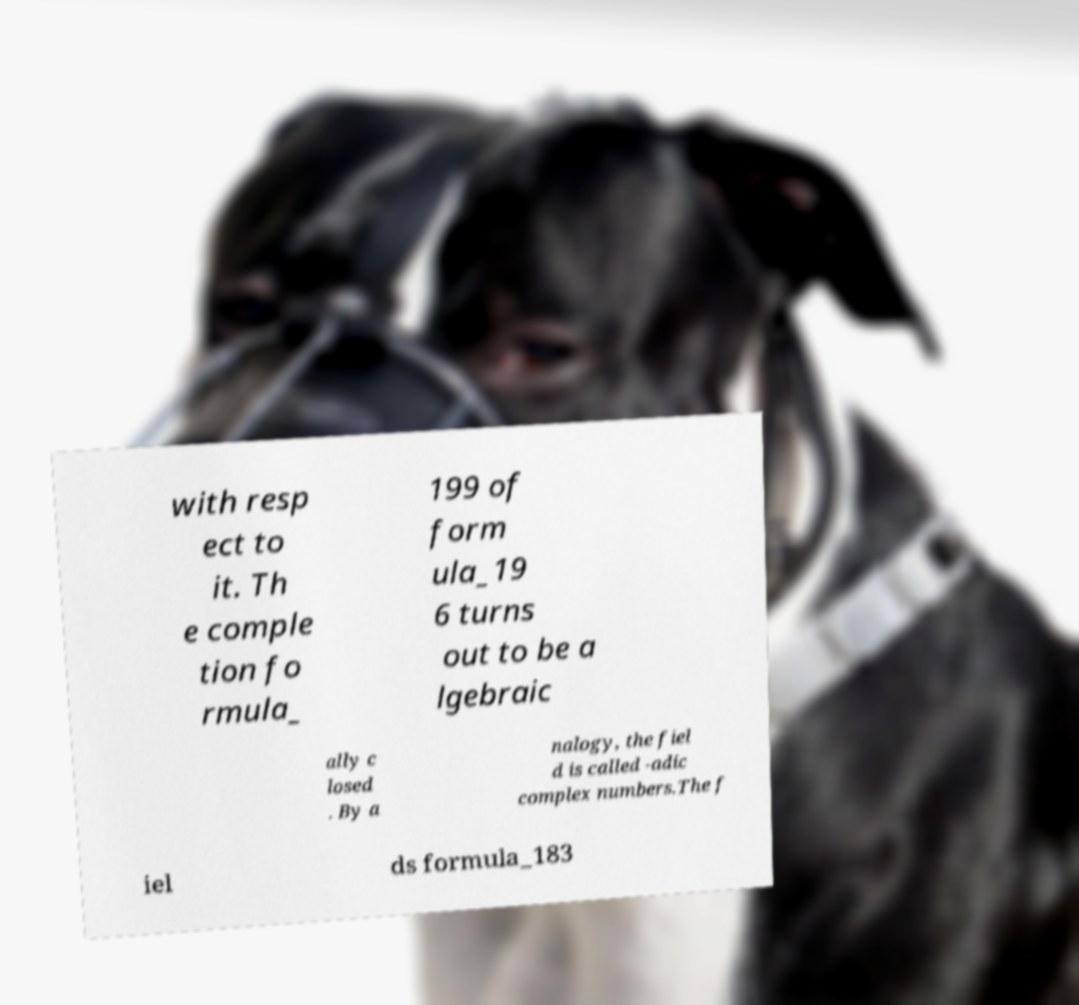Can you accurately transcribe the text from the provided image for me? with resp ect to it. Th e comple tion fo rmula_ 199 of form ula_19 6 turns out to be a lgebraic ally c losed . By a nalogy, the fiel d is called -adic complex numbers.The f iel ds formula_183 